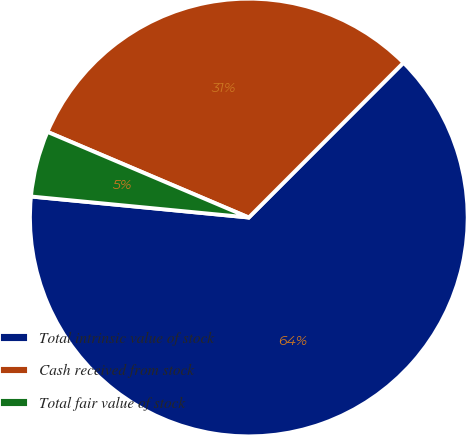Convert chart. <chart><loc_0><loc_0><loc_500><loc_500><pie_chart><fcel>Total intrinsic value of stock<fcel>Cash received from stock<fcel>Total fair value of stock<nl><fcel>64.04%<fcel>31.09%<fcel>4.87%<nl></chart> 